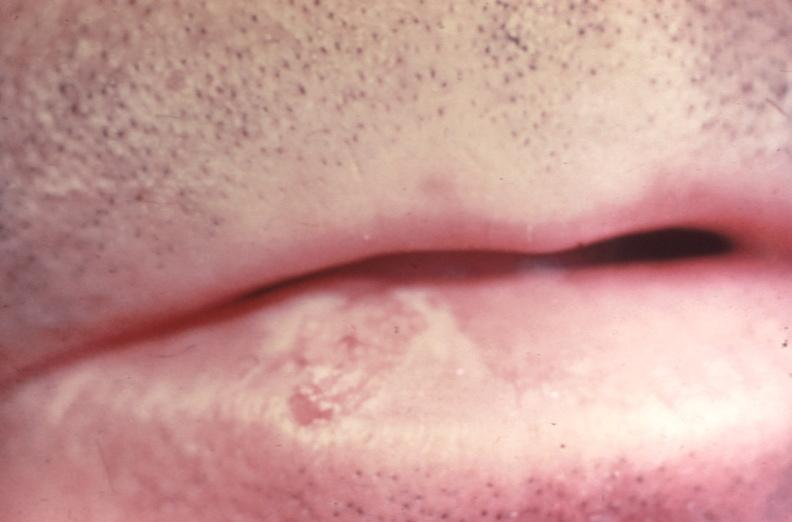where does this belong to?
Answer the question using a single word or phrase. Gastrointestinal system 